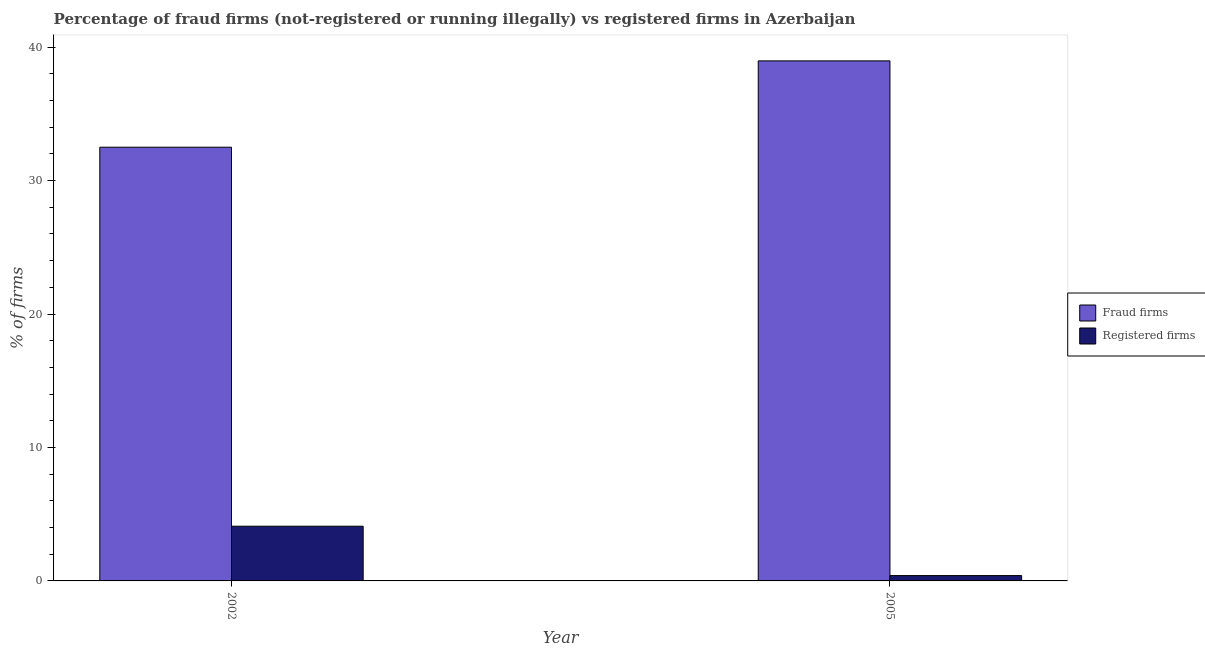How many groups of bars are there?
Keep it short and to the point. 2. What is the label of the 2nd group of bars from the left?
Make the answer very short. 2005. In how many cases, is the number of bars for a given year not equal to the number of legend labels?
Your answer should be compact. 0. What is the percentage of registered firms in 2002?
Offer a terse response. 4.1. Across all years, what is the maximum percentage of registered firms?
Your response must be concise. 4.1. In which year was the percentage of registered firms maximum?
Provide a short and direct response. 2002. What is the total percentage of fraud firms in the graph?
Offer a terse response. 71.47. What is the difference between the percentage of fraud firms in 2002 and that in 2005?
Your answer should be compact. -6.47. What is the difference between the percentage of registered firms in 2005 and the percentage of fraud firms in 2002?
Ensure brevity in your answer.  -3.7. What is the average percentage of registered firms per year?
Offer a terse response. 2.25. In the year 2002, what is the difference between the percentage of fraud firms and percentage of registered firms?
Offer a terse response. 0. What is the ratio of the percentage of registered firms in 2002 to that in 2005?
Your answer should be very brief. 10.25. Is the percentage of registered firms in 2002 less than that in 2005?
Offer a terse response. No. What does the 2nd bar from the left in 2005 represents?
Your answer should be compact. Registered firms. What does the 1st bar from the right in 2002 represents?
Offer a terse response. Registered firms. How many bars are there?
Offer a very short reply. 4. Where does the legend appear in the graph?
Offer a terse response. Center right. How many legend labels are there?
Provide a short and direct response. 2. What is the title of the graph?
Give a very brief answer. Percentage of fraud firms (not-registered or running illegally) vs registered firms in Azerbaijan. What is the label or title of the X-axis?
Give a very brief answer. Year. What is the label or title of the Y-axis?
Offer a terse response. % of firms. What is the % of firms of Fraud firms in 2002?
Your answer should be compact. 32.5. What is the % of firms of Registered firms in 2002?
Your answer should be very brief. 4.1. What is the % of firms of Fraud firms in 2005?
Your answer should be compact. 38.97. Across all years, what is the maximum % of firms of Fraud firms?
Your answer should be very brief. 38.97. Across all years, what is the maximum % of firms in Registered firms?
Offer a very short reply. 4.1. Across all years, what is the minimum % of firms in Fraud firms?
Provide a succinct answer. 32.5. What is the total % of firms of Fraud firms in the graph?
Provide a succinct answer. 71.47. What is the difference between the % of firms in Fraud firms in 2002 and that in 2005?
Provide a succinct answer. -6.47. What is the difference between the % of firms of Fraud firms in 2002 and the % of firms of Registered firms in 2005?
Offer a very short reply. 32.1. What is the average % of firms of Fraud firms per year?
Make the answer very short. 35.73. What is the average % of firms in Registered firms per year?
Your answer should be very brief. 2.25. In the year 2002, what is the difference between the % of firms in Fraud firms and % of firms in Registered firms?
Provide a short and direct response. 28.4. In the year 2005, what is the difference between the % of firms in Fraud firms and % of firms in Registered firms?
Ensure brevity in your answer.  38.57. What is the ratio of the % of firms of Fraud firms in 2002 to that in 2005?
Your answer should be very brief. 0.83. What is the ratio of the % of firms of Registered firms in 2002 to that in 2005?
Offer a very short reply. 10.25. What is the difference between the highest and the second highest % of firms of Fraud firms?
Give a very brief answer. 6.47. What is the difference between the highest and the lowest % of firms in Fraud firms?
Offer a very short reply. 6.47. 